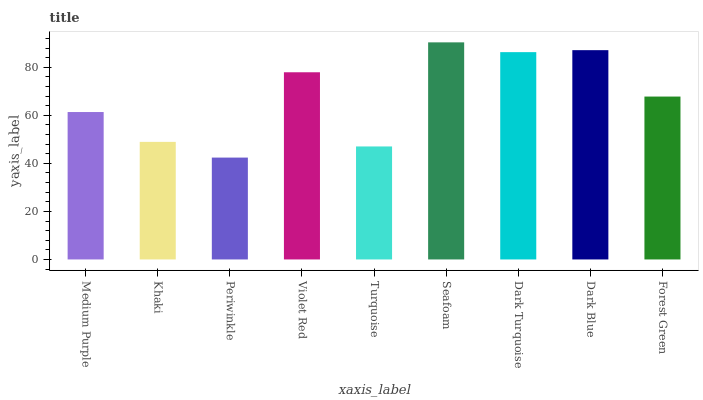Is Periwinkle the minimum?
Answer yes or no. Yes. Is Seafoam the maximum?
Answer yes or no. Yes. Is Khaki the minimum?
Answer yes or no. No. Is Khaki the maximum?
Answer yes or no. No. Is Medium Purple greater than Khaki?
Answer yes or no. Yes. Is Khaki less than Medium Purple?
Answer yes or no. Yes. Is Khaki greater than Medium Purple?
Answer yes or no. No. Is Medium Purple less than Khaki?
Answer yes or no. No. Is Forest Green the high median?
Answer yes or no. Yes. Is Forest Green the low median?
Answer yes or no. Yes. Is Dark Blue the high median?
Answer yes or no. No. Is Dark Turquoise the low median?
Answer yes or no. No. 